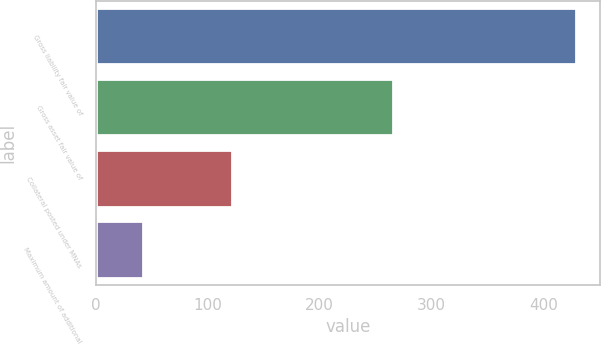Convert chart to OTSL. <chart><loc_0><loc_0><loc_500><loc_500><bar_chart><fcel>Gross liability fair value of<fcel>Gross asset fair value of<fcel>Collateral posted under MNAs<fcel>Maximum amount of additional<nl><fcel>429<fcel>265<fcel>122<fcel>42<nl></chart> 